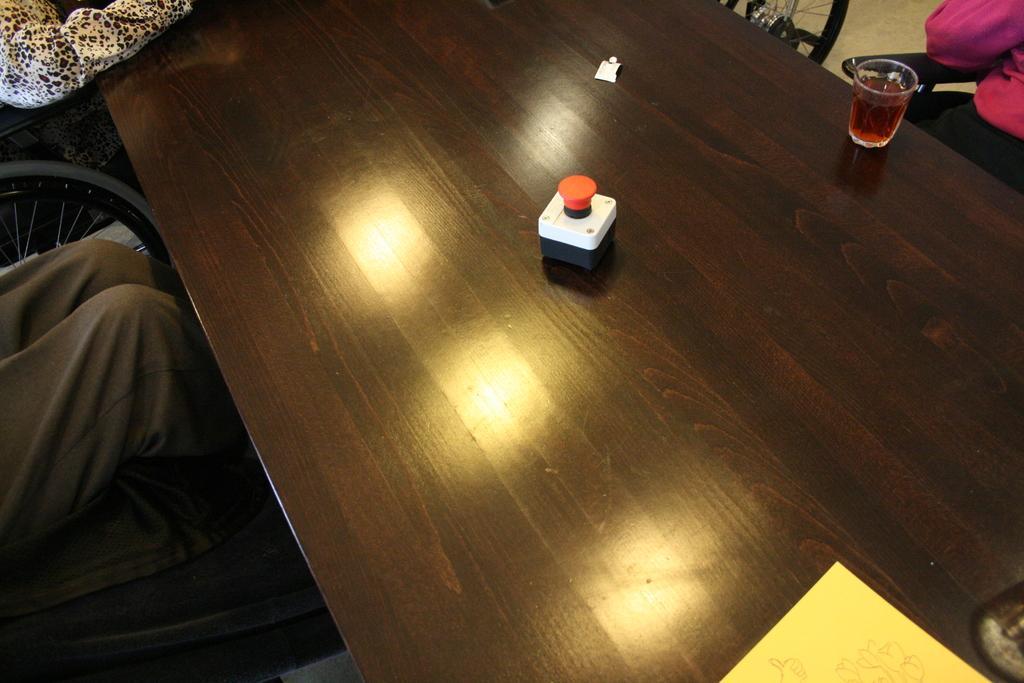In one or two sentences, can you explain what this image depicts? Here we can see a glass of drink and a device on the table and also a paper. At the right side of the picture we can see partial part of the human and same on the left side but here we can see a wheel chair. 